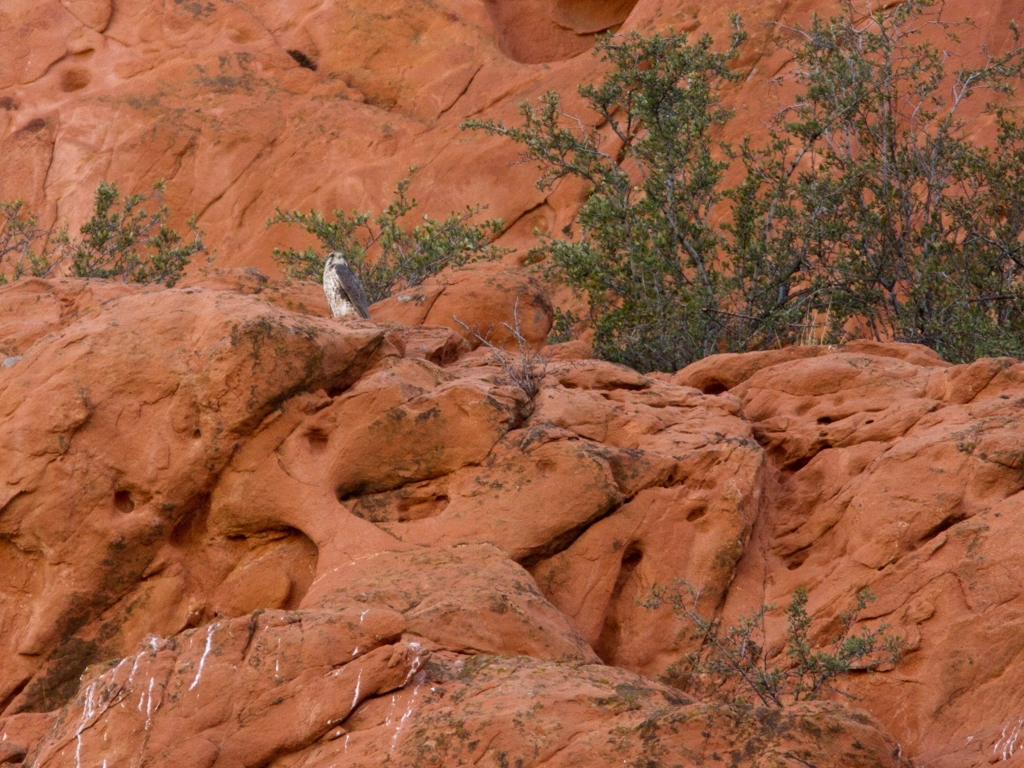What time of day does this image appear to have been taken? The photograph seems to have been taken during daytime, judging by the natural ambient light that is present. However, it is not brightly lit as one would expect at midday, suggesting it could be either morning or late afternoon. 